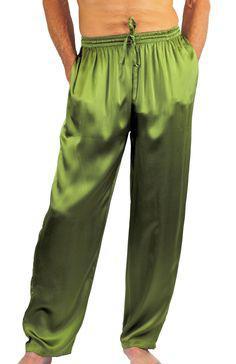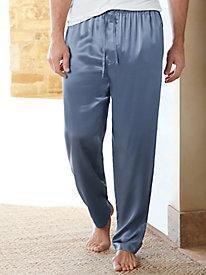The first image is the image on the left, the second image is the image on the right. Evaluate the accuracy of this statement regarding the images: "There are two pairs of pants". Is it true? Answer yes or no. Yes. 